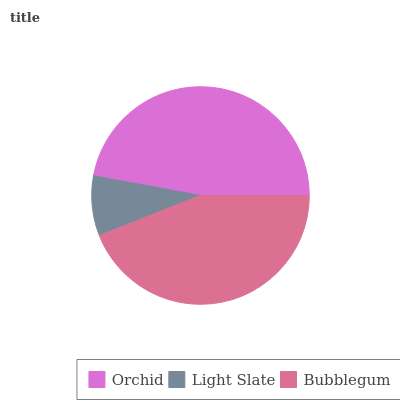Is Light Slate the minimum?
Answer yes or no. Yes. Is Orchid the maximum?
Answer yes or no. Yes. Is Bubblegum the minimum?
Answer yes or no. No. Is Bubblegum the maximum?
Answer yes or no. No. Is Bubblegum greater than Light Slate?
Answer yes or no. Yes. Is Light Slate less than Bubblegum?
Answer yes or no. Yes. Is Light Slate greater than Bubblegum?
Answer yes or no. No. Is Bubblegum less than Light Slate?
Answer yes or no. No. Is Bubblegum the high median?
Answer yes or no. Yes. Is Bubblegum the low median?
Answer yes or no. Yes. Is Light Slate the high median?
Answer yes or no. No. Is Light Slate the low median?
Answer yes or no. No. 